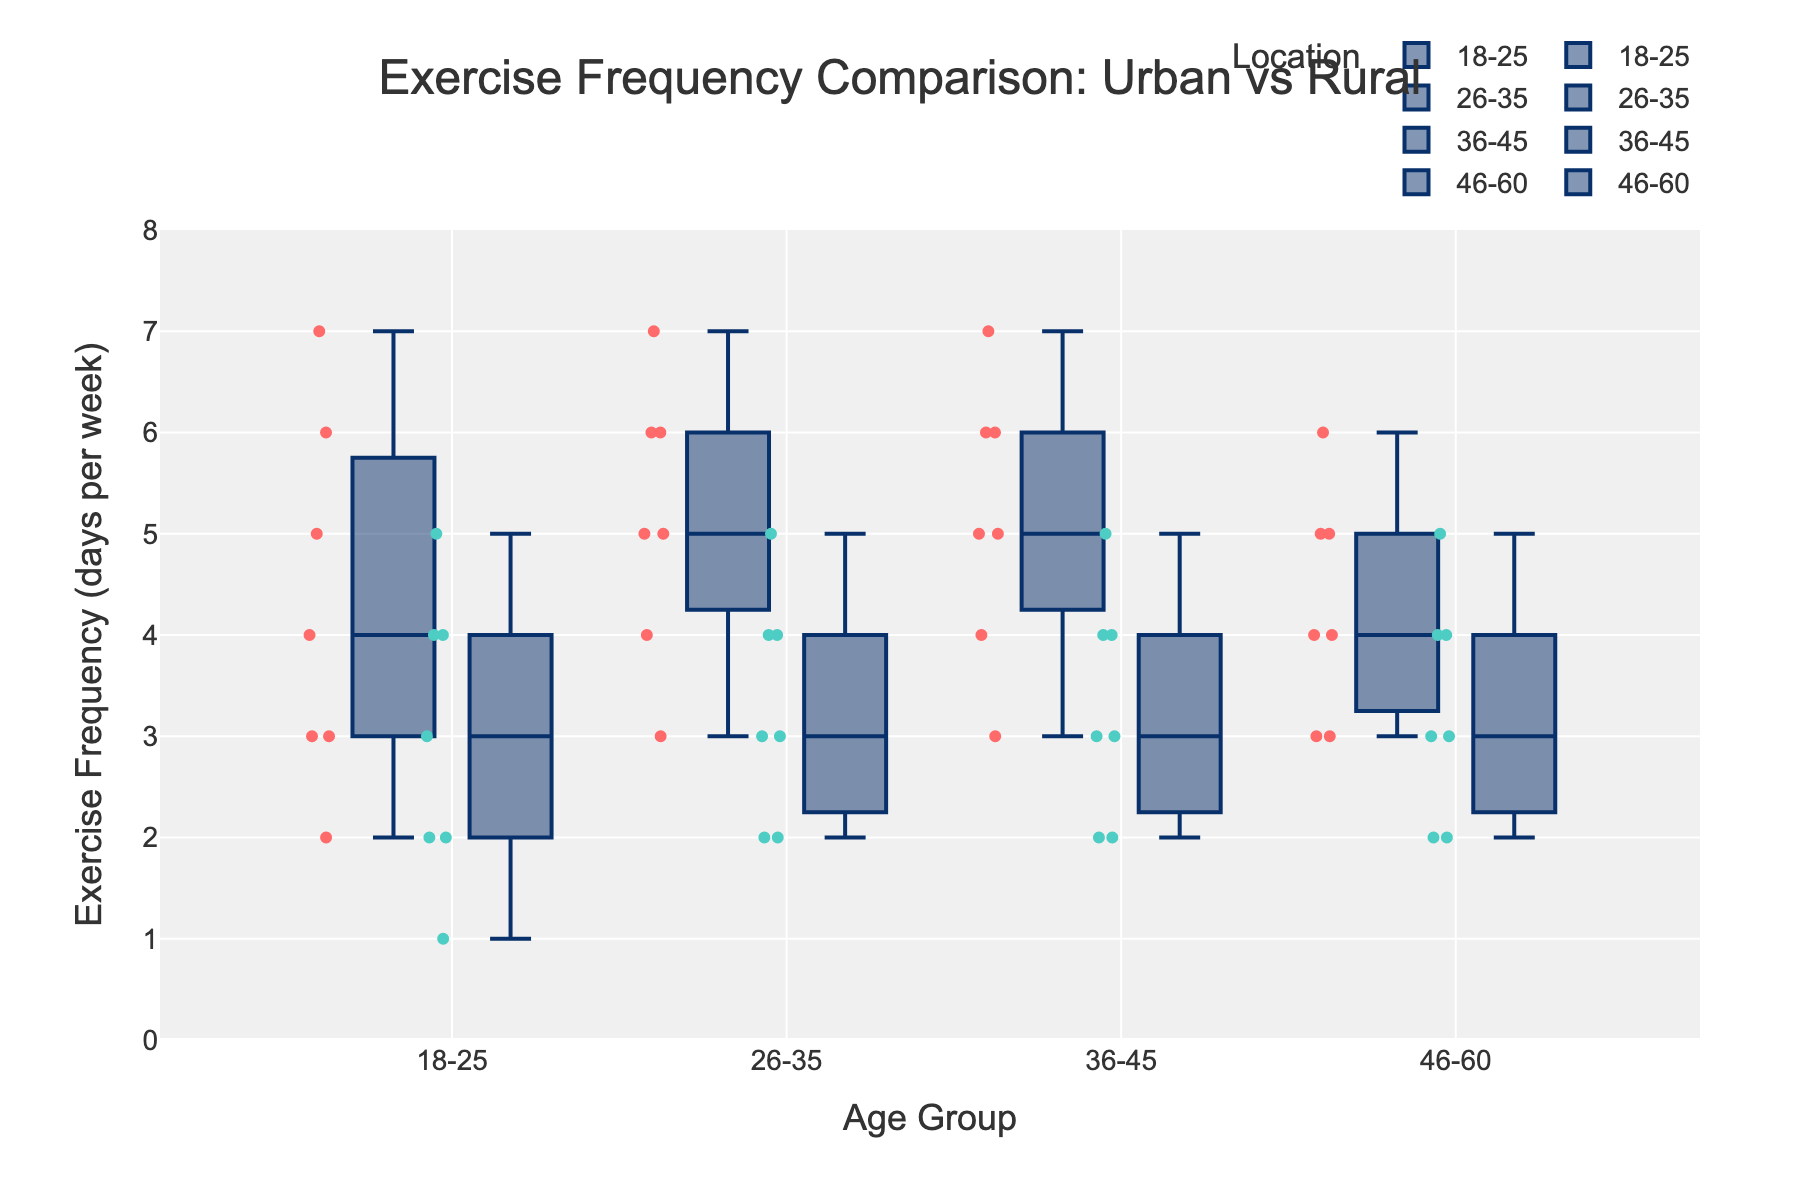What is the title of the figure? The title is centered at the top of the figure and provides an overview of the data being visualized. It reads "Exercise Frequency Comparison: Urban vs Rural".
Answer: Exercise Frequency Comparison: Urban vs Rural Which age group shows the highest exercise frequency in urban areas? To determine this, observe the grouped box plot for urban locations and compare the upper bounds. For urban areas, 36-45 shows the highest exercise frequency with data points reaching up to 7.
Answer: 36-45 What is the median exercise frequency for the rural 26-35 age group? In the box plot, the median value is represented by the line inside the box. For the rural 26-35 age group, the median is at 3.5.
Answer: 3.5 How does the overall exercise frequency in urban areas compare to rural areas? Visually compare the median lines, interquartile ranges, and whiskers of the box plots for urban and rural groups across all age groups. Urban areas generally show higher medians and longer upper whiskers.
Answer: Urban areas show higher exercise frequency What is the interquartile range (IQR) for the exercise frequency of urban 18-25 age group? IQR is the range between the first quartile (Q1) and the third quartile (Q3). For urban 18-25, Q1 is around 3 and Q3 is around 6. Therefore, IQR = 6 - 3.
Answer: 3 In which age group is the difference in median exercise frequency between urban and rural areas the largest? Compare the medians for each age group between urban and rural locations. The largest difference in medians is in the 26-35 age group, with 5.5 for urban and 3.5 for rural, giving a difference of 2.
Answer: 26-35 Are there any outliers visible in any of the groups? Outliers in a box plot are typically represented as individual points outside the whiskers. Observing the figure, there are no points marked outside the whiskers in any group, indicating no visible outliers.
Answer: No What is the range of exercise frequencies for the rural 36-45 age group? The range is determined by the whiskers of the box plot, which denote the minimum and maximum data points. For rural 36-45, range is from 2 to 5.
Answer: 2 to 5 Does any age group in the rural location have a higher median exercise frequency than its corresponding urban age group? Compare the median lines for each age group between rural and urban locations. For all age groups, urban medians are equal to or higher than rural medians.
Answer: No 